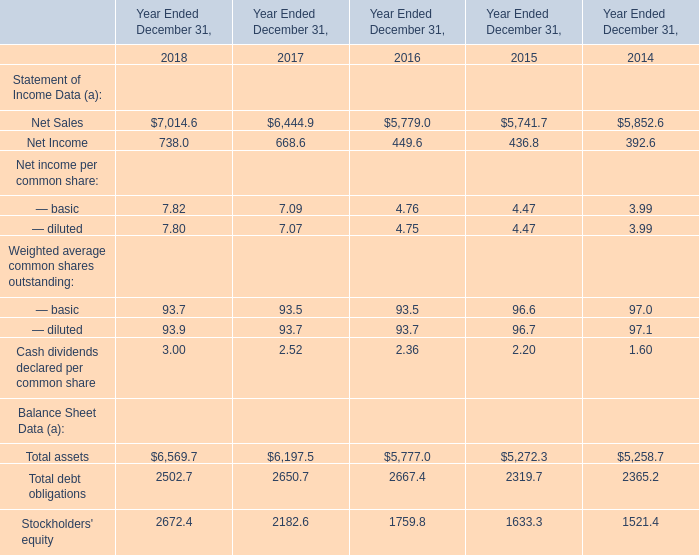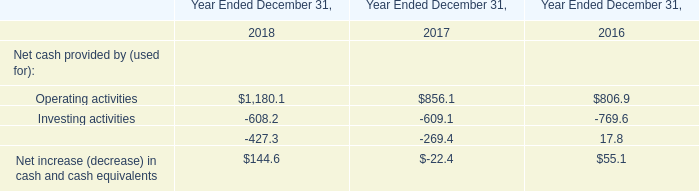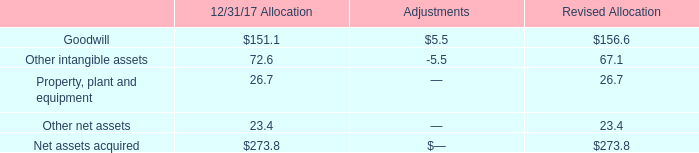In the year with the greatest proportion of — basic, what is the proportion of — basic to the tatal? 
Computations: (7.82 / ((((7.82 + 7.09) + 4.76) + 4.47) + 3.99))
Answer: 0.278. 